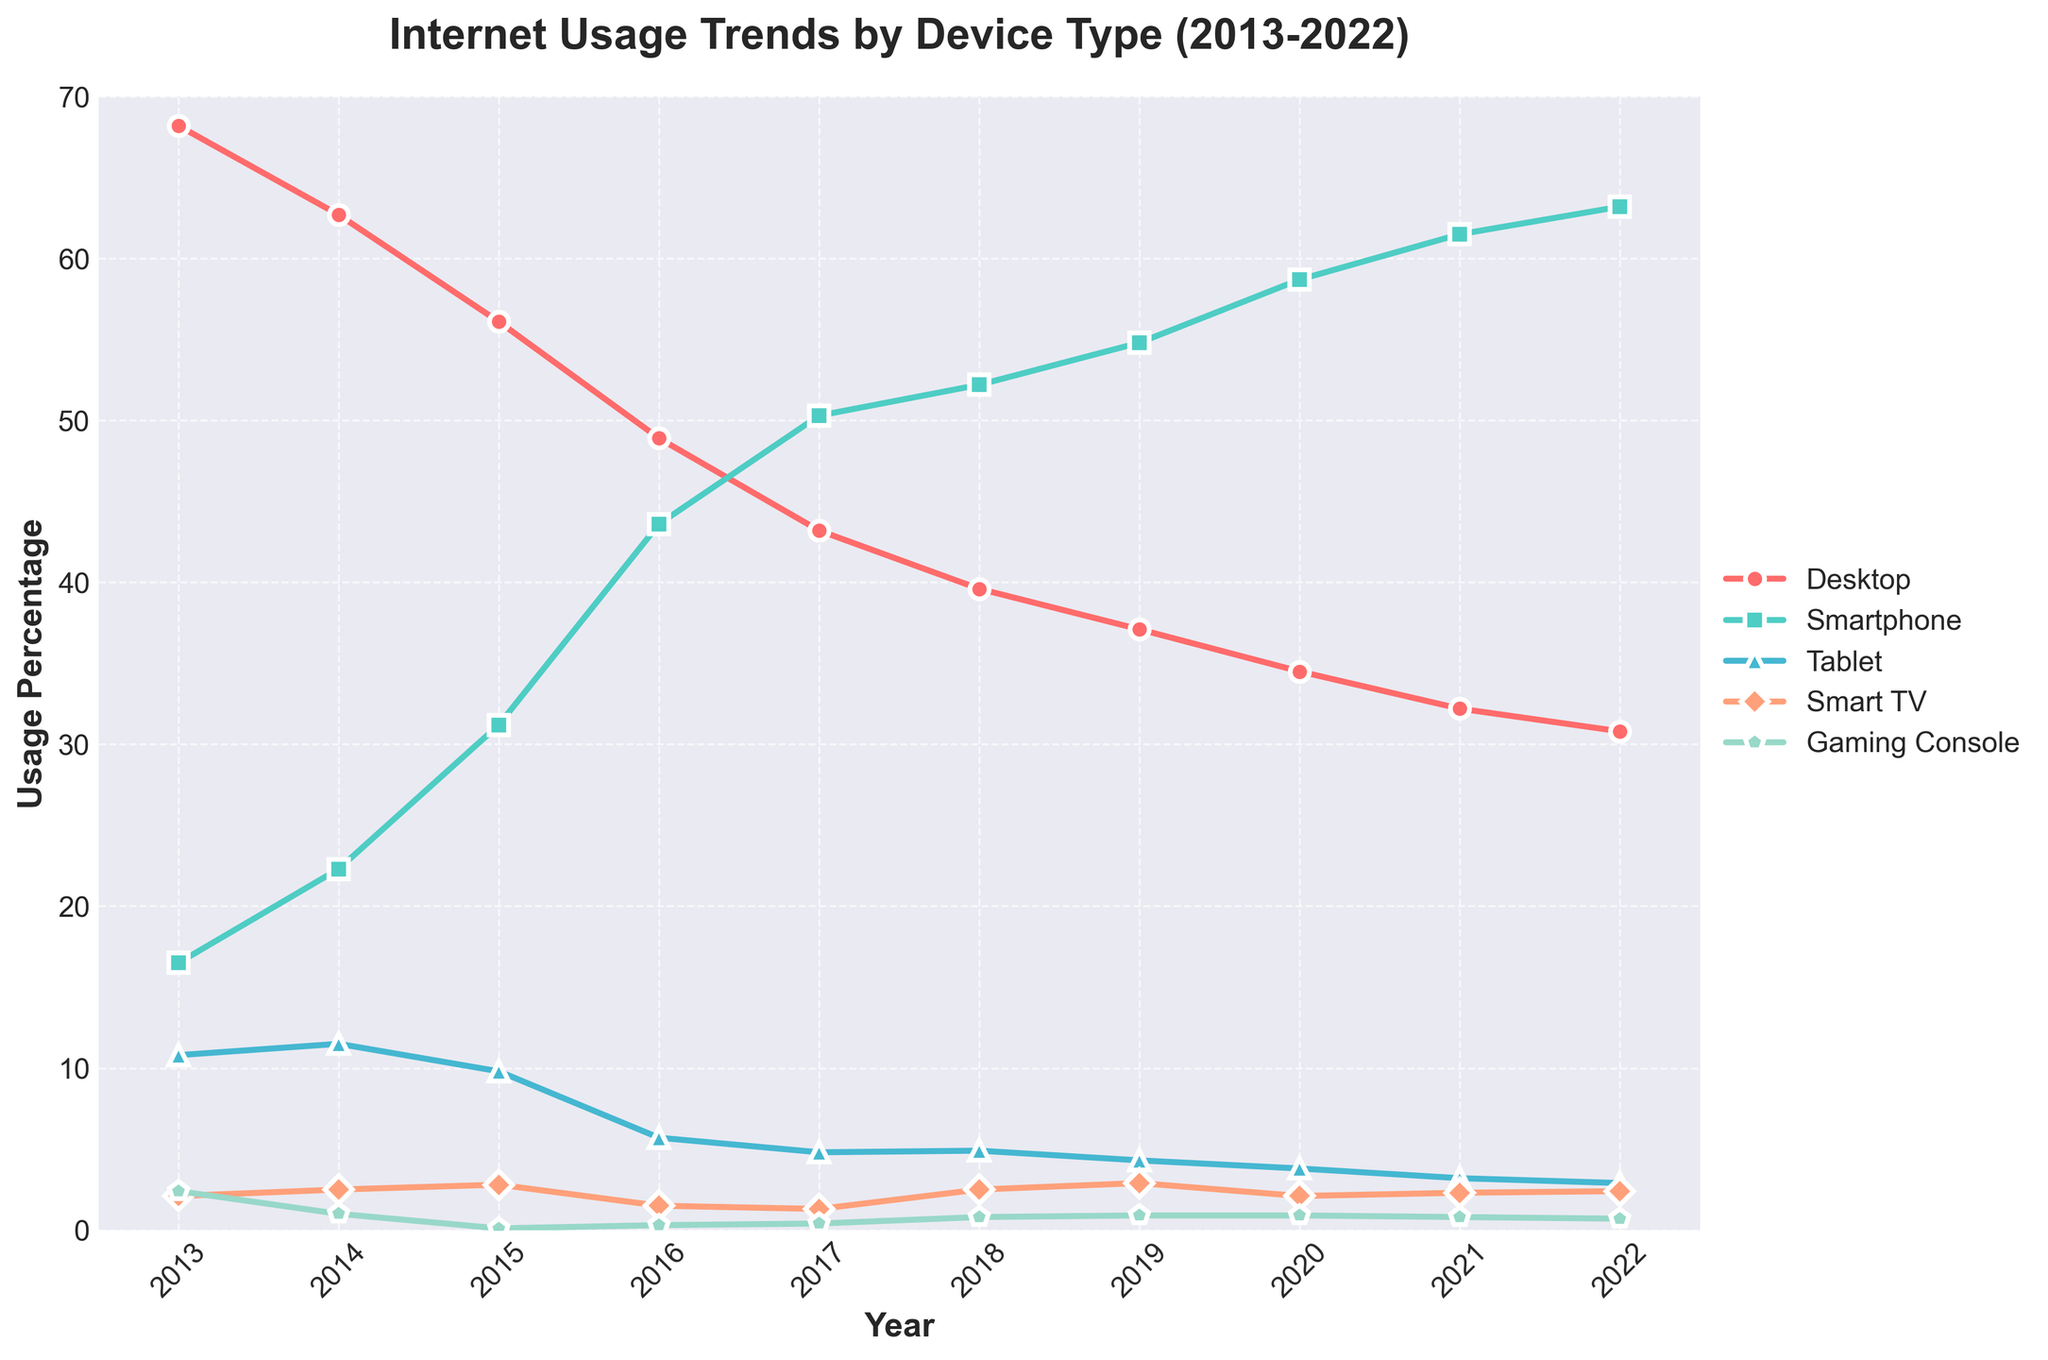Which device had the highest usage percentage in 2022? By looking at the endpoint of each line in 2022, the line corresponding to "Smartphone" is the highest.
Answer: Smartphone What is the overall trend for desktop usage from 2013 to 2022? Observing the line representing desktop usage, it consistently decreases from 68.2% in 2013 to 30.8% in 2022.
Answer: Decreasing Between what years did smartphone usage see the most significant increase? Look for the steepest slope in the line representing smartphone usage. The steepest slope appears between 2014 and 2016, going from 22.3% to 43.6%.
Answer: 2014-2016 By how much did gaming console usage decrease from 2013 to 2022? In 2013, gaming console usage was at 2.4%. In 2022, it was at 0.7%. The decrease is 2.4% - 0.7% = 1.7%.
Answer: 1.7% What was the approximate combined usage percentage of tablets and smart TVs in 2020? In 2020, tablet usage was 3.8% and smart TV usage was 2.1%. The combined usage is 3.8% + 2.1% = 5.9%.
Answer: 5.9% Which device type had the smallest change in usage percentage over the decade? By comparing the differences between the start and end points for each line, we see smart TV usage changes from 2.1% to 2.4% — a change of 0.3%, the smallest among all devices.
Answer: Smart TV Between 2018 and 2019, did any device type have an increasing trend while another had a decreasing trend? If so, which? Smartphone usage increased from 52.2% to 54.8%, while tablet usage decreased from 4.9% to 4.3%.
Answer: Smartphone and Tablet What is the average smartphone usage percentage from 2016 to 2022? Adding up the smartphone usage percentages from 2016 to 2022 (43.6%, 50.3%, 52.2%, 54.8%, 58.7%, 61.5%, 63.2%) and dividing by 7 gives (43.6 + 50.3 + 52.2 + 54.8 + 58.7 + 61.5 + 63.2) / 7 = 54.9%.
Answer: 54.9% In which year did tablet usage drop below 5% for the first time? Tablet usage drops below 5% from 2016 onwards.
Answer: 2016 